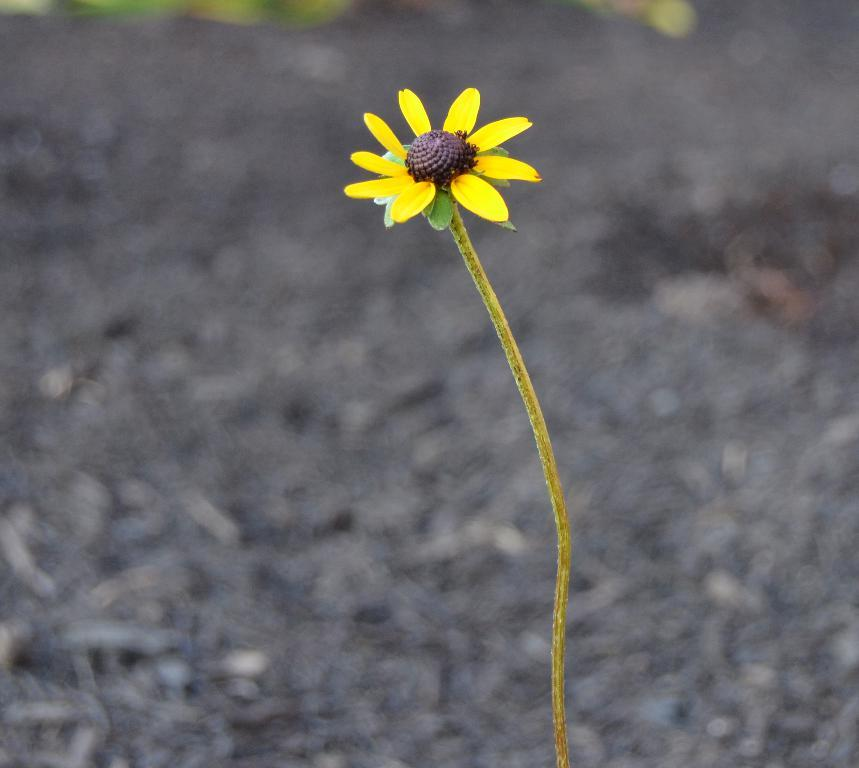What is the main subject of the image? There is a flower in the image. Is the flower stuck in quicksand in the image? There is no quicksand present in the image, and the flower is not depicted as being stuck in any substance. How many pizzas are shown being added together in the image? There are no pizzas present in the image; it features a flower. 